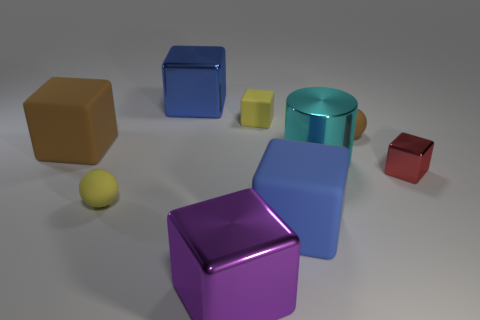There is a matte thing that is on the right side of the big blue rubber cube; is its color the same as the rubber block on the left side of the yellow block?
Your answer should be compact. Yes. What number of large objects have the same material as the tiny brown object?
Offer a very short reply. 2. There is a red shiny thing; does it have the same size as the yellow rubber object that is in front of the cylinder?
Give a very brief answer. Yes. What is the material of the ball that is the same color as the tiny matte block?
Provide a short and direct response. Rubber. What size is the metal thing that is behind the tiny rubber object right of the rubber cube that is to the right of the yellow cube?
Give a very brief answer. Large. Are there more large shiny things behind the small yellow matte sphere than cyan objects that are behind the brown block?
Your answer should be compact. Yes. There is a big shiny block that is behind the small shiny thing; what number of yellow matte balls are on the right side of it?
Provide a short and direct response. 0. Is there a matte object that has the same color as the small matte cube?
Keep it short and to the point. Yes. Do the red object and the brown matte ball have the same size?
Your answer should be compact. Yes. There is a big block that is in front of the matte block that is in front of the large cyan metal thing; what is it made of?
Make the answer very short. Metal. 